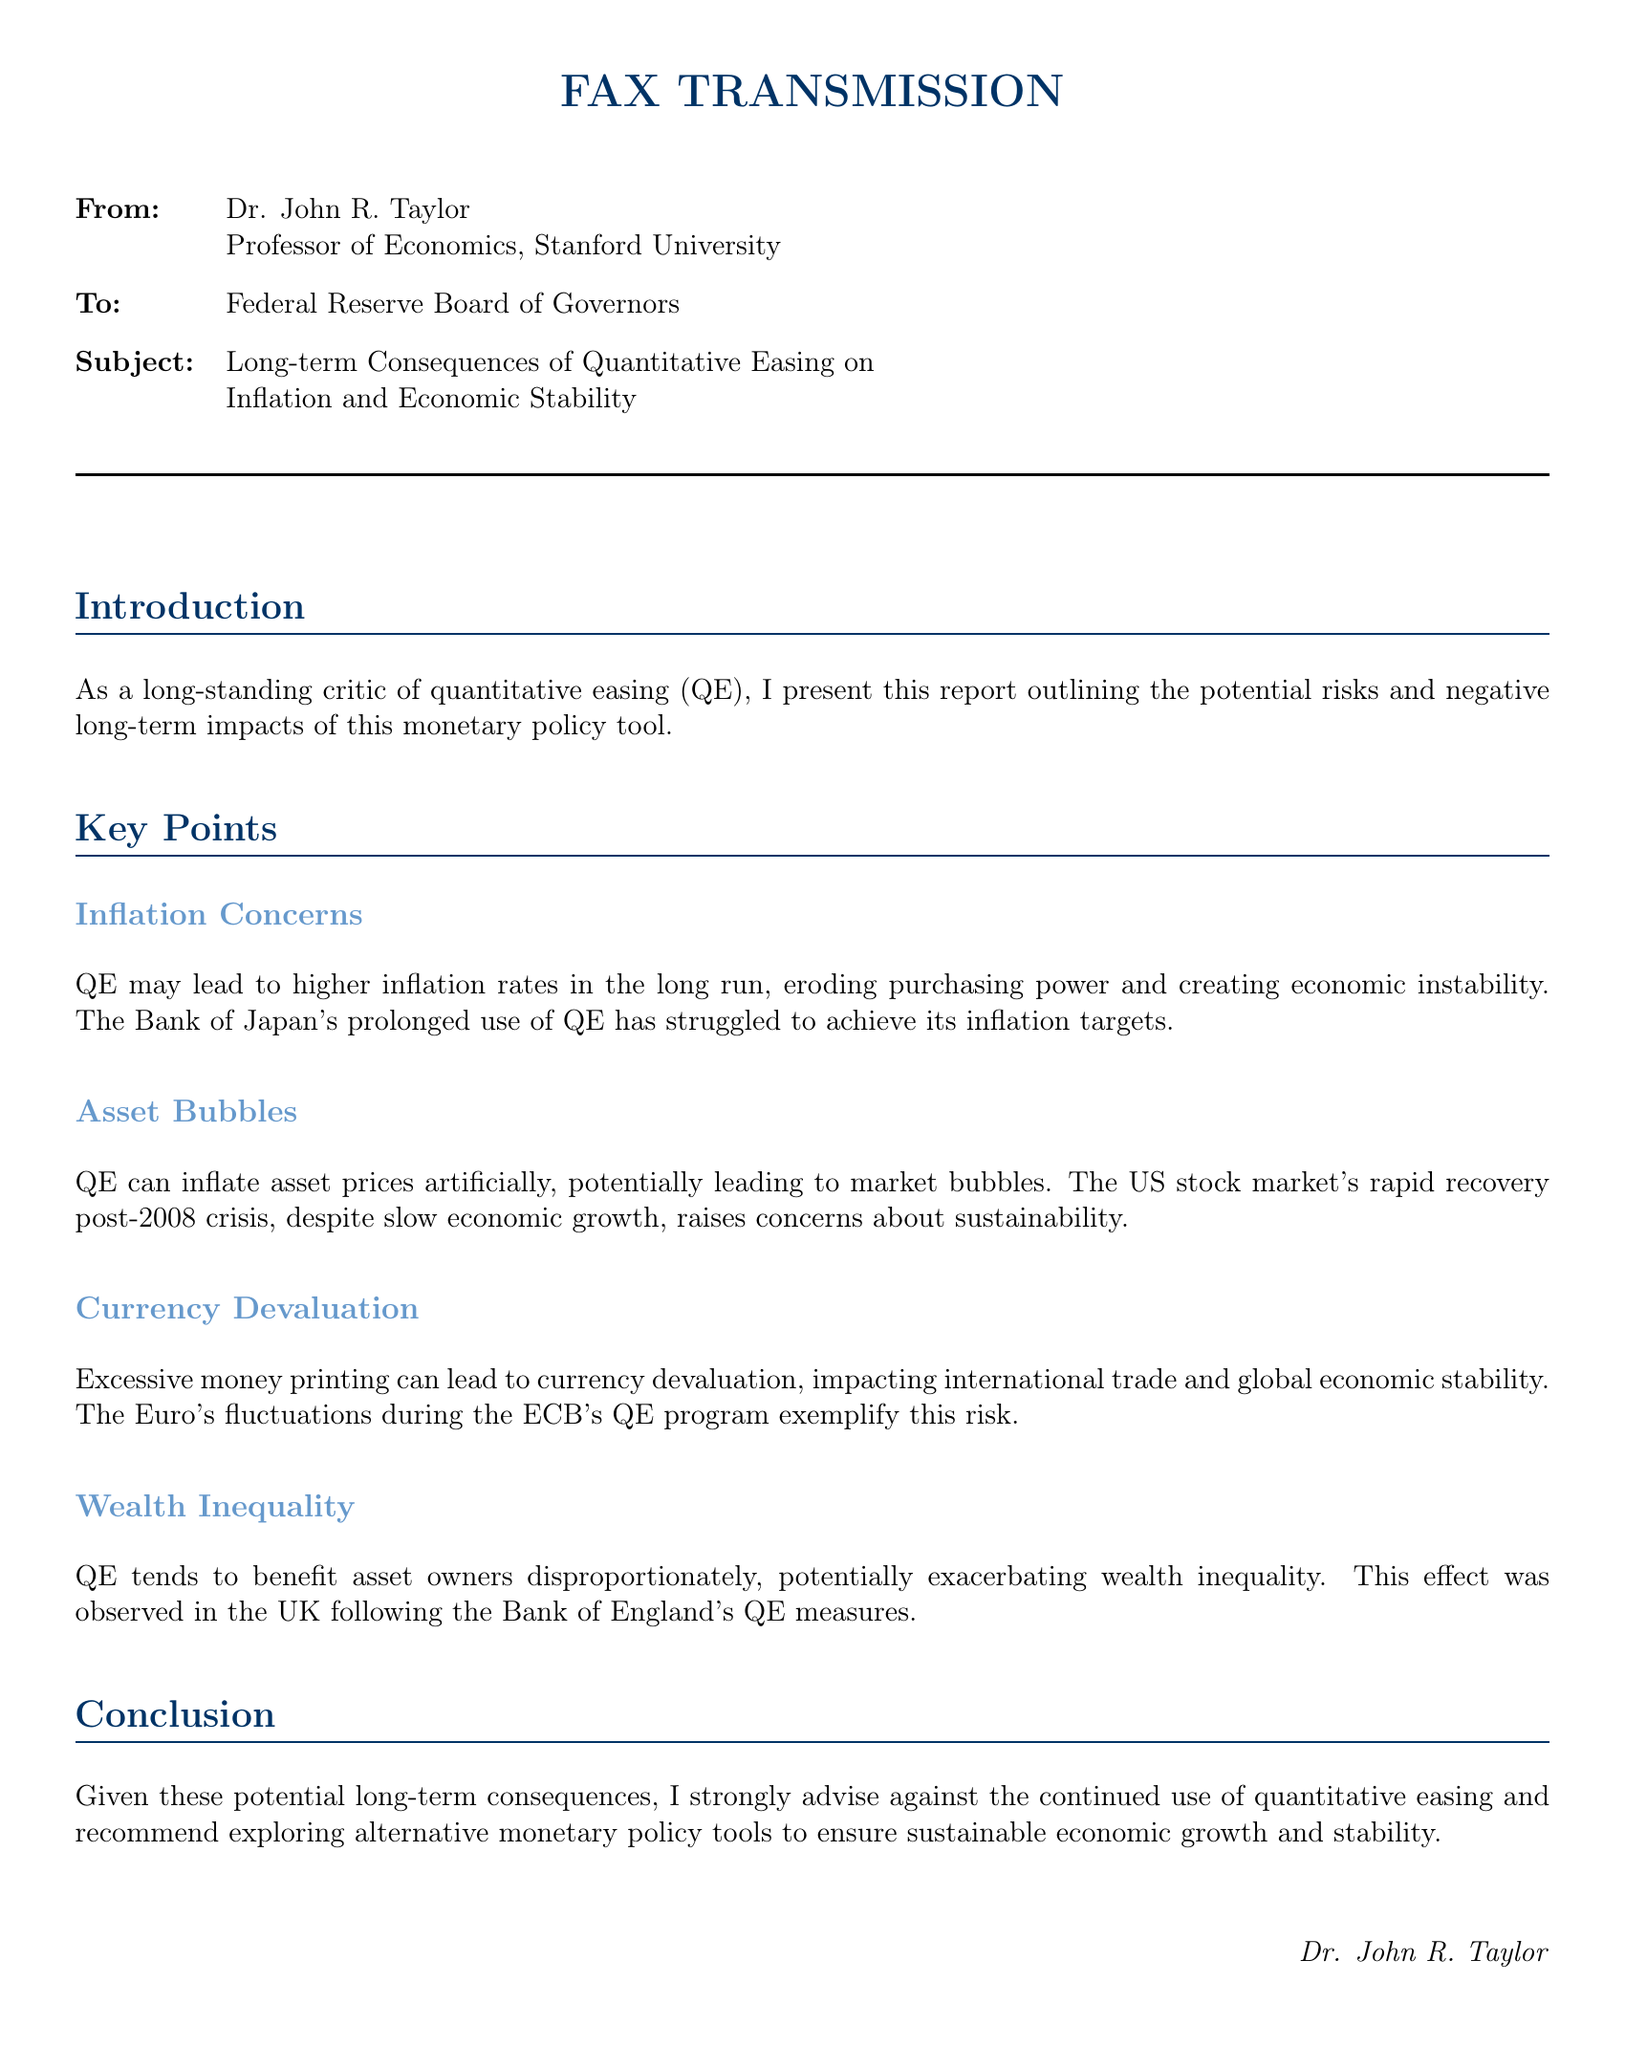What is the subject of the fax? The subject of the fax discusses the long-term consequences of quantitative easing on inflation and economic stability.
Answer: Long-term Consequences of Quantitative Easing on Inflation and Economic Stability Who is the sender of the fax? The sender of the fax is identified as Dr. John R. Taylor, who is a Professor of Economics at Stanford University.
Answer: Dr. John R. Taylor What concern is raised regarding inflation? The document raises a concern that QE may lead to higher inflation rates in the long run, eroding purchasing power and creating economic instability.
Answer: Higher inflation rates What potential impact does QE have on asset prices? The fax states that QE can inflate asset prices artificially, which could lead to market bubbles.
Answer: Inflate asset prices artificially What does the document suggest about wealth inequality? The document suggests that QE tends to benefit asset owners disproportionately, potentially exacerbating wealth inequality.
Answer: Exacerbating wealth inequality What is the recommendation given at the conclusion? The conclusion strongly advises against the continued use of quantitative easing and suggests exploring alternative monetary policy tools.
Answer: Advise against continued use of quantitative easing What historical example is mentioned in relation to currency devaluation? The document mentions the Euro's fluctuations during the ECB's QE program as an example of currency devaluation risk.
Answer: Euro's fluctuations during the ECB's QE program What monetary policy tool is criticized in this document? The document criticizes quantitative easing as a monetary policy tool.
Answer: Quantitative easing 